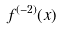Convert formula to latex. <formula><loc_0><loc_0><loc_500><loc_500>f ^ { ( - 2 ) } ( x )</formula> 